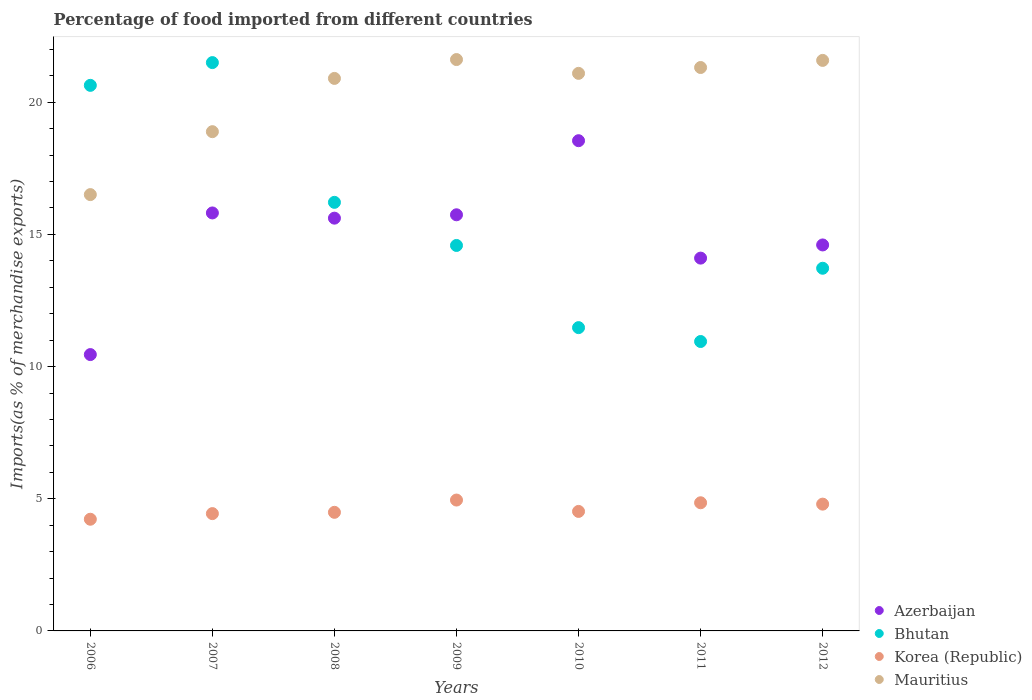How many different coloured dotlines are there?
Your response must be concise. 4. What is the percentage of imports to different countries in Azerbaijan in 2012?
Keep it short and to the point. 14.6. Across all years, what is the maximum percentage of imports to different countries in Mauritius?
Provide a succinct answer. 21.61. Across all years, what is the minimum percentage of imports to different countries in Bhutan?
Your answer should be compact. 10.95. In which year was the percentage of imports to different countries in Mauritius maximum?
Offer a terse response. 2009. What is the total percentage of imports to different countries in Mauritius in the graph?
Give a very brief answer. 141.9. What is the difference between the percentage of imports to different countries in Mauritius in 2007 and that in 2008?
Offer a very short reply. -2.01. What is the difference between the percentage of imports to different countries in Bhutan in 2010 and the percentage of imports to different countries in Azerbaijan in 2008?
Your answer should be compact. -4.14. What is the average percentage of imports to different countries in Mauritius per year?
Provide a short and direct response. 20.27. In the year 2010, what is the difference between the percentage of imports to different countries in Korea (Republic) and percentage of imports to different countries in Azerbaijan?
Your answer should be very brief. -14.02. In how many years, is the percentage of imports to different countries in Azerbaijan greater than 2 %?
Ensure brevity in your answer.  7. What is the ratio of the percentage of imports to different countries in Mauritius in 2006 to that in 2008?
Offer a very short reply. 0.79. Is the percentage of imports to different countries in Bhutan in 2006 less than that in 2011?
Make the answer very short. No. What is the difference between the highest and the second highest percentage of imports to different countries in Mauritius?
Your answer should be compact. 0.03. What is the difference between the highest and the lowest percentage of imports to different countries in Korea (Republic)?
Make the answer very short. 0.73. In how many years, is the percentage of imports to different countries in Bhutan greater than the average percentage of imports to different countries in Bhutan taken over all years?
Offer a terse response. 3. Is the sum of the percentage of imports to different countries in Korea (Republic) in 2007 and 2009 greater than the maximum percentage of imports to different countries in Azerbaijan across all years?
Provide a succinct answer. No. Does the percentage of imports to different countries in Bhutan monotonically increase over the years?
Give a very brief answer. No. Is the percentage of imports to different countries in Mauritius strictly less than the percentage of imports to different countries in Bhutan over the years?
Provide a succinct answer. No. How many years are there in the graph?
Keep it short and to the point. 7. Are the values on the major ticks of Y-axis written in scientific E-notation?
Your answer should be compact. No. Does the graph contain any zero values?
Ensure brevity in your answer.  No. Does the graph contain grids?
Make the answer very short. No. What is the title of the graph?
Your answer should be compact. Percentage of food imported from different countries. Does "Thailand" appear as one of the legend labels in the graph?
Keep it short and to the point. No. What is the label or title of the X-axis?
Keep it short and to the point. Years. What is the label or title of the Y-axis?
Offer a terse response. Imports(as % of merchandise exports). What is the Imports(as % of merchandise exports) in Azerbaijan in 2006?
Make the answer very short. 10.45. What is the Imports(as % of merchandise exports) in Bhutan in 2006?
Make the answer very short. 20.64. What is the Imports(as % of merchandise exports) of Korea (Republic) in 2006?
Give a very brief answer. 4.23. What is the Imports(as % of merchandise exports) of Mauritius in 2006?
Provide a short and direct response. 16.51. What is the Imports(as % of merchandise exports) in Azerbaijan in 2007?
Your answer should be very brief. 15.81. What is the Imports(as % of merchandise exports) in Bhutan in 2007?
Provide a succinct answer. 21.5. What is the Imports(as % of merchandise exports) in Korea (Republic) in 2007?
Keep it short and to the point. 4.44. What is the Imports(as % of merchandise exports) in Mauritius in 2007?
Offer a terse response. 18.89. What is the Imports(as % of merchandise exports) of Azerbaijan in 2008?
Give a very brief answer. 15.61. What is the Imports(as % of merchandise exports) of Bhutan in 2008?
Ensure brevity in your answer.  16.21. What is the Imports(as % of merchandise exports) in Korea (Republic) in 2008?
Make the answer very short. 4.49. What is the Imports(as % of merchandise exports) of Mauritius in 2008?
Give a very brief answer. 20.9. What is the Imports(as % of merchandise exports) of Azerbaijan in 2009?
Your answer should be compact. 15.74. What is the Imports(as % of merchandise exports) of Bhutan in 2009?
Give a very brief answer. 14.58. What is the Imports(as % of merchandise exports) of Korea (Republic) in 2009?
Provide a succinct answer. 4.95. What is the Imports(as % of merchandise exports) of Mauritius in 2009?
Your answer should be very brief. 21.61. What is the Imports(as % of merchandise exports) of Azerbaijan in 2010?
Your answer should be very brief. 18.54. What is the Imports(as % of merchandise exports) in Bhutan in 2010?
Your response must be concise. 11.47. What is the Imports(as % of merchandise exports) of Korea (Republic) in 2010?
Make the answer very short. 4.52. What is the Imports(as % of merchandise exports) of Mauritius in 2010?
Give a very brief answer. 21.09. What is the Imports(as % of merchandise exports) in Azerbaijan in 2011?
Provide a succinct answer. 14.1. What is the Imports(as % of merchandise exports) of Bhutan in 2011?
Your answer should be very brief. 10.95. What is the Imports(as % of merchandise exports) in Korea (Republic) in 2011?
Your answer should be compact. 4.85. What is the Imports(as % of merchandise exports) in Mauritius in 2011?
Ensure brevity in your answer.  21.31. What is the Imports(as % of merchandise exports) of Azerbaijan in 2012?
Offer a terse response. 14.6. What is the Imports(as % of merchandise exports) in Bhutan in 2012?
Your response must be concise. 13.72. What is the Imports(as % of merchandise exports) of Korea (Republic) in 2012?
Keep it short and to the point. 4.8. What is the Imports(as % of merchandise exports) in Mauritius in 2012?
Your answer should be compact. 21.58. Across all years, what is the maximum Imports(as % of merchandise exports) of Azerbaijan?
Ensure brevity in your answer.  18.54. Across all years, what is the maximum Imports(as % of merchandise exports) of Bhutan?
Give a very brief answer. 21.5. Across all years, what is the maximum Imports(as % of merchandise exports) in Korea (Republic)?
Give a very brief answer. 4.95. Across all years, what is the maximum Imports(as % of merchandise exports) in Mauritius?
Give a very brief answer. 21.61. Across all years, what is the minimum Imports(as % of merchandise exports) of Azerbaijan?
Your response must be concise. 10.45. Across all years, what is the minimum Imports(as % of merchandise exports) of Bhutan?
Your answer should be very brief. 10.95. Across all years, what is the minimum Imports(as % of merchandise exports) of Korea (Republic)?
Your answer should be compact. 4.23. Across all years, what is the minimum Imports(as % of merchandise exports) of Mauritius?
Make the answer very short. 16.51. What is the total Imports(as % of merchandise exports) in Azerbaijan in the graph?
Make the answer very short. 104.87. What is the total Imports(as % of merchandise exports) of Bhutan in the graph?
Ensure brevity in your answer.  109.08. What is the total Imports(as % of merchandise exports) of Korea (Republic) in the graph?
Give a very brief answer. 32.27. What is the total Imports(as % of merchandise exports) in Mauritius in the graph?
Give a very brief answer. 141.9. What is the difference between the Imports(as % of merchandise exports) of Azerbaijan in 2006 and that in 2007?
Give a very brief answer. -5.36. What is the difference between the Imports(as % of merchandise exports) of Bhutan in 2006 and that in 2007?
Make the answer very short. -0.86. What is the difference between the Imports(as % of merchandise exports) of Korea (Republic) in 2006 and that in 2007?
Ensure brevity in your answer.  -0.21. What is the difference between the Imports(as % of merchandise exports) of Mauritius in 2006 and that in 2007?
Give a very brief answer. -2.38. What is the difference between the Imports(as % of merchandise exports) of Azerbaijan in 2006 and that in 2008?
Keep it short and to the point. -5.16. What is the difference between the Imports(as % of merchandise exports) in Bhutan in 2006 and that in 2008?
Make the answer very short. 4.43. What is the difference between the Imports(as % of merchandise exports) of Korea (Republic) in 2006 and that in 2008?
Give a very brief answer. -0.26. What is the difference between the Imports(as % of merchandise exports) of Mauritius in 2006 and that in 2008?
Your response must be concise. -4.4. What is the difference between the Imports(as % of merchandise exports) of Azerbaijan in 2006 and that in 2009?
Offer a very short reply. -5.29. What is the difference between the Imports(as % of merchandise exports) of Bhutan in 2006 and that in 2009?
Ensure brevity in your answer.  6.06. What is the difference between the Imports(as % of merchandise exports) of Korea (Republic) in 2006 and that in 2009?
Your response must be concise. -0.73. What is the difference between the Imports(as % of merchandise exports) of Mauritius in 2006 and that in 2009?
Provide a succinct answer. -5.11. What is the difference between the Imports(as % of merchandise exports) in Azerbaijan in 2006 and that in 2010?
Provide a short and direct response. -8.09. What is the difference between the Imports(as % of merchandise exports) of Bhutan in 2006 and that in 2010?
Offer a very short reply. 9.17. What is the difference between the Imports(as % of merchandise exports) in Korea (Republic) in 2006 and that in 2010?
Offer a terse response. -0.3. What is the difference between the Imports(as % of merchandise exports) in Mauritius in 2006 and that in 2010?
Your response must be concise. -4.59. What is the difference between the Imports(as % of merchandise exports) of Azerbaijan in 2006 and that in 2011?
Offer a terse response. -3.65. What is the difference between the Imports(as % of merchandise exports) in Bhutan in 2006 and that in 2011?
Your answer should be compact. 9.69. What is the difference between the Imports(as % of merchandise exports) in Korea (Republic) in 2006 and that in 2011?
Make the answer very short. -0.62. What is the difference between the Imports(as % of merchandise exports) in Mauritius in 2006 and that in 2011?
Give a very brief answer. -4.81. What is the difference between the Imports(as % of merchandise exports) of Azerbaijan in 2006 and that in 2012?
Offer a terse response. -4.15. What is the difference between the Imports(as % of merchandise exports) of Bhutan in 2006 and that in 2012?
Provide a short and direct response. 6.92. What is the difference between the Imports(as % of merchandise exports) in Korea (Republic) in 2006 and that in 2012?
Offer a very short reply. -0.57. What is the difference between the Imports(as % of merchandise exports) of Mauritius in 2006 and that in 2012?
Offer a terse response. -5.08. What is the difference between the Imports(as % of merchandise exports) of Azerbaijan in 2007 and that in 2008?
Offer a terse response. 0.2. What is the difference between the Imports(as % of merchandise exports) in Bhutan in 2007 and that in 2008?
Ensure brevity in your answer.  5.29. What is the difference between the Imports(as % of merchandise exports) of Korea (Republic) in 2007 and that in 2008?
Keep it short and to the point. -0.05. What is the difference between the Imports(as % of merchandise exports) of Mauritius in 2007 and that in 2008?
Make the answer very short. -2.02. What is the difference between the Imports(as % of merchandise exports) of Azerbaijan in 2007 and that in 2009?
Give a very brief answer. 0.07. What is the difference between the Imports(as % of merchandise exports) of Bhutan in 2007 and that in 2009?
Offer a very short reply. 6.92. What is the difference between the Imports(as % of merchandise exports) of Korea (Republic) in 2007 and that in 2009?
Offer a very short reply. -0.51. What is the difference between the Imports(as % of merchandise exports) of Mauritius in 2007 and that in 2009?
Offer a very short reply. -2.73. What is the difference between the Imports(as % of merchandise exports) in Azerbaijan in 2007 and that in 2010?
Offer a terse response. -2.73. What is the difference between the Imports(as % of merchandise exports) of Bhutan in 2007 and that in 2010?
Offer a very short reply. 10.03. What is the difference between the Imports(as % of merchandise exports) in Korea (Republic) in 2007 and that in 2010?
Give a very brief answer. -0.08. What is the difference between the Imports(as % of merchandise exports) of Mauritius in 2007 and that in 2010?
Your response must be concise. -2.21. What is the difference between the Imports(as % of merchandise exports) of Azerbaijan in 2007 and that in 2011?
Provide a short and direct response. 1.71. What is the difference between the Imports(as % of merchandise exports) of Bhutan in 2007 and that in 2011?
Your answer should be very brief. 10.55. What is the difference between the Imports(as % of merchandise exports) in Korea (Republic) in 2007 and that in 2011?
Provide a succinct answer. -0.41. What is the difference between the Imports(as % of merchandise exports) of Mauritius in 2007 and that in 2011?
Keep it short and to the point. -2.43. What is the difference between the Imports(as % of merchandise exports) of Azerbaijan in 2007 and that in 2012?
Ensure brevity in your answer.  1.21. What is the difference between the Imports(as % of merchandise exports) in Bhutan in 2007 and that in 2012?
Provide a succinct answer. 7.78. What is the difference between the Imports(as % of merchandise exports) in Korea (Republic) in 2007 and that in 2012?
Ensure brevity in your answer.  -0.36. What is the difference between the Imports(as % of merchandise exports) in Mauritius in 2007 and that in 2012?
Your answer should be compact. -2.7. What is the difference between the Imports(as % of merchandise exports) of Azerbaijan in 2008 and that in 2009?
Make the answer very short. -0.13. What is the difference between the Imports(as % of merchandise exports) in Bhutan in 2008 and that in 2009?
Your response must be concise. 1.63. What is the difference between the Imports(as % of merchandise exports) in Korea (Republic) in 2008 and that in 2009?
Provide a short and direct response. -0.46. What is the difference between the Imports(as % of merchandise exports) of Mauritius in 2008 and that in 2009?
Give a very brief answer. -0.71. What is the difference between the Imports(as % of merchandise exports) in Azerbaijan in 2008 and that in 2010?
Offer a terse response. -2.93. What is the difference between the Imports(as % of merchandise exports) in Bhutan in 2008 and that in 2010?
Provide a short and direct response. 4.74. What is the difference between the Imports(as % of merchandise exports) of Korea (Republic) in 2008 and that in 2010?
Keep it short and to the point. -0.03. What is the difference between the Imports(as % of merchandise exports) in Mauritius in 2008 and that in 2010?
Offer a very short reply. -0.19. What is the difference between the Imports(as % of merchandise exports) in Azerbaijan in 2008 and that in 2011?
Your answer should be compact. 1.51. What is the difference between the Imports(as % of merchandise exports) in Bhutan in 2008 and that in 2011?
Keep it short and to the point. 5.26. What is the difference between the Imports(as % of merchandise exports) in Korea (Republic) in 2008 and that in 2011?
Make the answer very short. -0.36. What is the difference between the Imports(as % of merchandise exports) in Mauritius in 2008 and that in 2011?
Give a very brief answer. -0.41. What is the difference between the Imports(as % of merchandise exports) of Azerbaijan in 2008 and that in 2012?
Your response must be concise. 1.01. What is the difference between the Imports(as % of merchandise exports) in Bhutan in 2008 and that in 2012?
Offer a very short reply. 2.49. What is the difference between the Imports(as % of merchandise exports) of Korea (Republic) in 2008 and that in 2012?
Your answer should be compact. -0.31. What is the difference between the Imports(as % of merchandise exports) in Mauritius in 2008 and that in 2012?
Your response must be concise. -0.68. What is the difference between the Imports(as % of merchandise exports) of Azerbaijan in 2009 and that in 2010?
Keep it short and to the point. -2.8. What is the difference between the Imports(as % of merchandise exports) of Bhutan in 2009 and that in 2010?
Your answer should be compact. 3.11. What is the difference between the Imports(as % of merchandise exports) in Korea (Republic) in 2009 and that in 2010?
Make the answer very short. 0.43. What is the difference between the Imports(as % of merchandise exports) of Mauritius in 2009 and that in 2010?
Offer a terse response. 0.52. What is the difference between the Imports(as % of merchandise exports) of Azerbaijan in 2009 and that in 2011?
Your answer should be compact. 1.64. What is the difference between the Imports(as % of merchandise exports) in Bhutan in 2009 and that in 2011?
Offer a very short reply. 3.63. What is the difference between the Imports(as % of merchandise exports) of Korea (Republic) in 2009 and that in 2011?
Provide a succinct answer. 0.1. What is the difference between the Imports(as % of merchandise exports) of Mauritius in 2009 and that in 2011?
Your answer should be compact. 0.3. What is the difference between the Imports(as % of merchandise exports) of Azerbaijan in 2009 and that in 2012?
Make the answer very short. 1.14. What is the difference between the Imports(as % of merchandise exports) of Bhutan in 2009 and that in 2012?
Make the answer very short. 0.86. What is the difference between the Imports(as % of merchandise exports) of Korea (Republic) in 2009 and that in 2012?
Your answer should be compact. 0.15. What is the difference between the Imports(as % of merchandise exports) in Mauritius in 2009 and that in 2012?
Keep it short and to the point. 0.03. What is the difference between the Imports(as % of merchandise exports) of Azerbaijan in 2010 and that in 2011?
Offer a terse response. 4.44. What is the difference between the Imports(as % of merchandise exports) in Bhutan in 2010 and that in 2011?
Your answer should be very brief. 0.52. What is the difference between the Imports(as % of merchandise exports) of Korea (Republic) in 2010 and that in 2011?
Your answer should be compact. -0.33. What is the difference between the Imports(as % of merchandise exports) of Mauritius in 2010 and that in 2011?
Your answer should be compact. -0.22. What is the difference between the Imports(as % of merchandise exports) in Azerbaijan in 2010 and that in 2012?
Provide a short and direct response. 3.94. What is the difference between the Imports(as % of merchandise exports) of Bhutan in 2010 and that in 2012?
Keep it short and to the point. -2.25. What is the difference between the Imports(as % of merchandise exports) of Korea (Republic) in 2010 and that in 2012?
Keep it short and to the point. -0.28. What is the difference between the Imports(as % of merchandise exports) of Mauritius in 2010 and that in 2012?
Your answer should be very brief. -0.49. What is the difference between the Imports(as % of merchandise exports) of Azerbaijan in 2011 and that in 2012?
Offer a terse response. -0.5. What is the difference between the Imports(as % of merchandise exports) of Bhutan in 2011 and that in 2012?
Ensure brevity in your answer.  -2.77. What is the difference between the Imports(as % of merchandise exports) in Korea (Republic) in 2011 and that in 2012?
Give a very brief answer. 0.05. What is the difference between the Imports(as % of merchandise exports) in Mauritius in 2011 and that in 2012?
Your answer should be compact. -0.27. What is the difference between the Imports(as % of merchandise exports) in Azerbaijan in 2006 and the Imports(as % of merchandise exports) in Bhutan in 2007?
Your answer should be very brief. -11.05. What is the difference between the Imports(as % of merchandise exports) of Azerbaijan in 2006 and the Imports(as % of merchandise exports) of Korea (Republic) in 2007?
Your response must be concise. 6.02. What is the difference between the Imports(as % of merchandise exports) in Azerbaijan in 2006 and the Imports(as % of merchandise exports) in Mauritius in 2007?
Ensure brevity in your answer.  -8.43. What is the difference between the Imports(as % of merchandise exports) of Bhutan in 2006 and the Imports(as % of merchandise exports) of Korea (Republic) in 2007?
Provide a short and direct response. 16.2. What is the difference between the Imports(as % of merchandise exports) of Bhutan in 2006 and the Imports(as % of merchandise exports) of Mauritius in 2007?
Give a very brief answer. 1.75. What is the difference between the Imports(as % of merchandise exports) of Korea (Republic) in 2006 and the Imports(as % of merchandise exports) of Mauritius in 2007?
Give a very brief answer. -14.66. What is the difference between the Imports(as % of merchandise exports) of Azerbaijan in 2006 and the Imports(as % of merchandise exports) of Bhutan in 2008?
Give a very brief answer. -5.76. What is the difference between the Imports(as % of merchandise exports) in Azerbaijan in 2006 and the Imports(as % of merchandise exports) in Korea (Republic) in 2008?
Provide a succinct answer. 5.97. What is the difference between the Imports(as % of merchandise exports) of Azerbaijan in 2006 and the Imports(as % of merchandise exports) of Mauritius in 2008?
Provide a short and direct response. -10.45. What is the difference between the Imports(as % of merchandise exports) in Bhutan in 2006 and the Imports(as % of merchandise exports) in Korea (Republic) in 2008?
Your answer should be compact. 16.15. What is the difference between the Imports(as % of merchandise exports) of Bhutan in 2006 and the Imports(as % of merchandise exports) of Mauritius in 2008?
Make the answer very short. -0.26. What is the difference between the Imports(as % of merchandise exports) of Korea (Republic) in 2006 and the Imports(as % of merchandise exports) of Mauritius in 2008?
Offer a terse response. -16.68. What is the difference between the Imports(as % of merchandise exports) in Azerbaijan in 2006 and the Imports(as % of merchandise exports) in Bhutan in 2009?
Your answer should be very brief. -4.13. What is the difference between the Imports(as % of merchandise exports) of Azerbaijan in 2006 and the Imports(as % of merchandise exports) of Korea (Republic) in 2009?
Your response must be concise. 5.5. What is the difference between the Imports(as % of merchandise exports) in Azerbaijan in 2006 and the Imports(as % of merchandise exports) in Mauritius in 2009?
Keep it short and to the point. -11.16. What is the difference between the Imports(as % of merchandise exports) of Bhutan in 2006 and the Imports(as % of merchandise exports) of Korea (Republic) in 2009?
Give a very brief answer. 15.69. What is the difference between the Imports(as % of merchandise exports) in Bhutan in 2006 and the Imports(as % of merchandise exports) in Mauritius in 2009?
Keep it short and to the point. -0.98. What is the difference between the Imports(as % of merchandise exports) in Korea (Republic) in 2006 and the Imports(as % of merchandise exports) in Mauritius in 2009?
Make the answer very short. -17.39. What is the difference between the Imports(as % of merchandise exports) in Azerbaijan in 2006 and the Imports(as % of merchandise exports) in Bhutan in 2010?
Provide a short and direct response. -1.02. What is the difference between the Imports(as % of merchandise exports) in Azerbaijan in 2006 and the Imports(as % of merchandise exports) in Korea (Republic) in 2010?
Ensure brevity in your answer.  5.93. What is the difference between the Imports(as % of merchandise exports) in Azerbaijan in 2006 and the Imports(as % of merchandise exports) in Mauritius in 2010?
Provide a succinct answer. -10.64. What is the difference between the Imports(as % of merchandise exports) in Bhutan in 2006 and the Imports(as % of merchandise exports) in Korea (Republic) in 2010?
Your response must be concise. 16.12. What is the difference between the Imports(as % of merchandise exports) of Bhutan in 2006 and the Imports(as % of merchandise exports) of Mauritius in 2010?
Your response must be concise. -0.45. What is the difference between the Imports(as % of merchandise exports) in Korea (Republic) in 2006 and the Imports(as % of merchandise exports) in Mauritius in 2010?
Give a very brief answer. -16.87. What is the difference between the Imports(as % of merchandise exports) of Azerbaijan in 2006 and the Imports(as % of merchandise exports) of Bhutan in 2011?
Your response must be concise. -0.49. What is the difference between the Imports(as % of merchandise exports) of Azerbaijan in 2006 and the Imports(as % of merchandise exports) of Korea (Republic) in 2011?
Your answer should be compact. 5.61. What is the difference between the Imports(as % of merchandise exports) in Azerbaijan in 2006 and the Imports(as % of merchandise exports) in Mauritius in 2011?
Offer a very short reply. -10.86. What is the difference between the Imports(as % of merchandise exports) of Bhutan in 2006 and the Imports(as % of merchandise exports) of Korea (Republic) in 2011?
Ensure brevity in your answer.  15.79. What is the difference between the Imports(as % of merchandise exports) of Bhutan in 2006 and the Imports(as % of merchandise exports) of Mauritius in 2011?
Provide a succinct answer. -0.67. What is the difference between the Imports(as % of merchandise exports) of Korea (Republic) in 2006 and the Imports(as % of merchandise exports) of Mauritius in 2011?
Provide a succinct answer. -17.09. What is the difference between the Imports(as % of merchandise exports) of Azerbaijan in 2006 and the Imports(as % of merchandise exports) of Bhutan in 2012?
Provide a succinct answer. -3.27. What is the difference between the Imports(as % of merchandise exports) in Azerbaijan in 2006 and the Imports(as % of merchandise exports) in Korea (Republic) in 2012?
Provide a succinct answer. 5.66. What is the difference between the Imports(as % of merchandise exports) in Azerbaijan in 2006 and the Imports(as % of merchandise exports) in Mauritius in 2012?
Your response must be concise. -11.13. What is the difference between the Imports(as % of merchandise exports) in Bhutan in 2006 and the Imports(as % of merchandise exports) in Korea (Republic) in 2012?
Make the answer very short. 15.84. What is the difference between the Imports(as % of merchandise exports) in Bhutan in 2006 and the Imports(as % of merchandise exports) in Mauritius in 2012?
Offer a very short reply. -0.94. What is the difference between the Imports(as % of merchandise exports) of Korea (Republic) in 2006 and the Imports(as % of merchandise exports) of Mauritius in 2012?
Your answer should be compact. -17.36. What is the difference between the Imports(as % of merchandise exports) in Azerbaijan in 2007 and the Imports(as % of merchandise exports) in Bhutan in 2008?
Provide a succinct answer. -0.4. What is the difference between the Imports(as % of merchandise exports) in Azerbaijan in 2007 and the Imports(as % of merchandise exports) in Korea (Republic) in 2008?
Provide a succinct answer. 11.33. What is the difference between the Imports(as % of merchandise exports) in Azerbaijan in 2007 and the Imports(as % of merchandise exports) in Mauritius in 2008?
Offer a terse response. -5.09. What is the difference between the Imports(as % of merchandise exports) of Bhutan in 2007 and the Imports(as % of merchandise exports) of Korea (Republic) in 2008?
Your answer should be compact. 17.01. What is the difference between the Imports(as % of merchandise exports) of Bhutan in 2007 and the Imports(as % of merchandise exports) of Mauritius in 2008?
Provide a succinct answer. 0.6. What is the difference between the Imports(as % of merchandise exports) of Korea (Republic) in 2007 and the Imports(as % of merchandise exports) of Mauritius in 2008?
Provide a succinct answer. -16.46. What is the difference between the Imports(as % of merchandise exports) of Azerbaijan in 2007 and the Imports(as % of merchandise exports) of Bhutan in 2009?
Your answer should be compact. 1.23. What is the difference between the Imports(as % of merchandise exports) of Azerbaijan in 2007 and the Imports(as % of merchandise exports) of Korea (Republic) in 2009?
Your answer should be compact. 10.86. What is the difference between the Imports(as % of merchandise exports) in Azerbaijan in 2007 and the Imports(as % of merchandise exports) in Mauritius in 2009?
Your answer should be compact. -5.8. What is the difference between the Imports(as % of merchandise exports) of Bhutan in 2007 and the Imports(as % of merchandise exports) of Korea (Republic) in 2009?
Your answer should be very brief. 16.55. What is the difference between the Imports(as % of merchandise exports) of Bhutan in 2007 and the Imports(as % of merchandise exports) of Mauritius in 2009?
Provide a short and direct response. -0.11. What is the difference between the Imports(as % of merchandise exports) of Korea (Republic) in 2007 and the Imports(as % of merchandise exports) of Mauritius in 2009?
Keep it short and to the point. -17.18. What is the difference between the Imports(as % of merchandise exports) in Azerbaijan in 2007 and the Imports(as % of merchandise exports) in Bhutan in 2010?
Provide a short and direct response. 4.34. What is the difference between the Imports(as % of merchandise exports) in Azerbaijan in 2007 and the Imports(as % of merchandise exports) in Korea (Republic) in 2010?
Offer a very short reply. 11.29. What is the difference between the Imports(as % of merchandise exports) of Azerbaijan in 2007 and the Imports(as % of merchandise exports) of Mauritius in 2010?
Your answer should be very brief. -5.28. What is the difference between the Imports(as % of merchandise exports) of Bhutan in 2007 and the Imports(as % of merchandise exports) of Korea (Republic) in 2010?
Provide a short and direct response. 16.98. What is the difference between the Imports(as % of merchandise exports) of Bhutan in 2007 and the Imports(as % of merchandise exports) of Mauritius in 2010?
Offer a very short reply. 0.41. What is the difference between the Imports(as % of merchandise exports) in Korea (Republic) in 2007 and the Imports(as % of merchandise exports) in Mauritius in 2010?
Provide a succinct answer. -16.65. What is the difference between the Imports(as % of merchandise exports) in Azerbaijan in 2007 and the Imports(as % of merchandise exports) in Bhutan in 2011?
Keep it short and to the point. 4.86. What is the difference between the Imports(as % of merchandise exports) of Azerbaijan in 2007 and the Imports(as % of merchandise exports) of Korea (Republic) in 2011?
Your answer should be compact. 10.96. What is the difference between the Imports(as % of merchandise exports) of Azerbaijan in 2007 and the Imports(as % of merchandise exports) of Mauritius in 2011?
Offer a very short reply. -5.5. What is the difference between the Imports(as % of merchandise exports) of Bhutan in 2007 and the Imports(as % of merchandise exports) of Korea (Republic) in 2011?
Keep it short and to the point. 16.65. What is the difference between the Imports(as % of merchandise exports) of Bhutan in 2007 and the Imports(as % of merchandise exports) of Mauritius in 2011?
Provide a short and direct response. 0.19. What is the difference between the Imports(as % of merchandise exports) in Korea (Republic) in 2007 and the Imports(as % of merchandise exports) in Mauritius in 2011?
Your response must be concise. -16.88. What is the difference between the Imports(as % of merchandise exports) in Azerbaijan in 2007 and the Imports(as % of merchandise exports) in Bhutan in 2012?
Offer a terse response. 2.09. What is the difference between the Imports(as % of merchandise exports) in Azerbaijan in 2007 and the Imports(as % of merchandise exports) in Korea (Republic) in 2012?
Keep it short and to the point. 11.02. What is the difference between the Imports(as % of merchandise exports) of Azerbaijan in 2007 and the Imports(as % of merchandise exports) of Mauritius in 2012?
Your response must be concise. -5.77. What is the difference between the Imports(as % of merchandise exports) of Bhutan in 2007 and the Imports(as % of merchandise exports) of Korea (Republic) in 2012?
Your answer should be very brief. 16.7. What is the difference between the Imports(as % of merchandise exports) in Bhutan in 2007 and the Imports(as % of merchandise exports) in Mauritius in 2012?
Provide a short and direct response. -0.08. What is the difference between the Imports(as % of merchandise exports) of Korea (Republic) in 2007 and the Imports(as % of merchandise exports) of Mauritius in 2012?
Offer a very short reply. -17.15. What is the difference between the Imports(as % of merchandise exports) of Azerbaijan in 2008 and the Imports(as % of merchandise exports) of Bhutan in 2009?
Offer a very short reply. 1.03. What is the difference between the Imports(as % of merchandise exports) of Azerbaijan in 2008 and the Imports(as % of merchandise exports) of Korea (Republic) in 2009?
Your response must be concise. 10.66. What is the difference between the Imports(as % of merchandise exports) in Azerbaijan in 2008 and the Imports(as % of merchandise exports) in Mauritius in 2009?
Provide a succinct answer. -6. What is the difference between the Imports(as % of merchandise exports) of Bhutan in 2008 and the Imports(as % of merchandise exports) of Korea (Republic) in 2009?
Provide a succinct answer. 11.26. What is the difference between the Imports(as % of merchandise exports) of Bhutan in 2008 and the Imports(as % of merchandise exports) of Mauritius in 2009?
Your response must be concise. -5.4. What is the difference between the Imports(as % of merchandise exports) in Korea (Republic) in 2008 and the Imports(as % of merchandise exports) in Mauritius in 2009?
Your response must be concise. -17.13. What is the difference between the Imports(as % of merchandise exports) in Azerbaijan in 2008 and the Imports(as % of merchandise exports) in Bhutan in 2010?
Your response must be concise. 4.14. What is the difference between the Imports(as % of merchandise exports) of Azerbaijan in 2008 and the Imports(as % of merchandise exports) of Korea (Republic) in 2010?
Your answer should be very brief. 11.09. What is the difference between the Imports(as % of merchandise exports) of Azerbaijan in 2008 and the Imports(as % of merchandise exports) of Mauritius in 2010?
Ensure brevity in your answer.  -5.48. What is the difference between the Imports(as % of merchandise exports) of Bhutan in 2008 and the Imports(as % of merchandise exports) of Korea (Republic) in 2010?
Your answer should be compact. 11.69. What is the difference between the Imports(as % of merchandise exports) in Bhutan in 2008 and the Imports(as % of merchandise exports) in Mauritius in 2010?
Ensure brevity in your answer.  -4.88. What is the difference between the Imports(as % of merchandise exports) in Korea (Republic) in 2008 and the Imports(as % of merchandise exports) in Mauritius in 2010?
Provide a succinct answer. -16.61. What is the difference between the Imports(as % of merchandise exports) in Azerbaijan in 2008 and the Imports(as % of merchandise exports) in Bhutan in 2011?
Provide a short and direct response. 4.67. What is the difference between the Imports(as % of merchandise exports) of Azerbaijan in 2008 and the Imports(as % of merchandise exports) of Korea (Republic) in 2011?
Offer a very short reply. 10.77. What is the difference between the Imports(as % of merchandise exports) in Azerbaijan in 2008 and the Imports(as % of merchandise exports) in Mauritius in 2011?
Ensure brevity in your answer.  -5.7. What is the difference between the Imports(as % of merchandise exports) of Bhutan in 2008 and the Imports(as % of merchandise exports) of Korea (Republic) in 2011?
Offer a very short reply. 11.36. What is the difference between the Imports(as % of merchandise exports) of Bhutan in 2008 and the Imports(as % of merchandise exports) of Mauritius in 2011?
Ensure brevity in your answer.  -5.1. What is the difference between the Imports(as % of merchandise exports) in Korea (Republic) in 2008 and the Imports(as % of merchandise exports) in Mauritius in 2011?
Your answer should be very brief. -16.83. What is the difference between the Imports(as % of merchandise exports) of Azerbaijan in 2008 and the Imports(as % of merchandise exports) of Bhutan in 2012?
Offer a very short reply. 1.9. What is the difference between the Imports(as % of merchandise exports) in Azerbaijan in 2008 and the Imports(as % of merchandise exports) in Korea (Republic) in 2012?
Your response must be concise. 10.82. What is the difference between the Imports(as % of merchandise exports) in Azerbaijan in 2008 and the Imports(as % of merchandise exports) in Mauritius in 2012?
Ensure brevity in your answer.  -5.97. What is the difference between the Imports(as % of merchandise exports) in Bhutan in 2008 and the Imports(as % of merchandise exports) in Korea (Republic) in 2012?
Ensure brevity in your answer.  11.42. What is the difference between the Imports(as % of merchandise exports) in Bhutan in 2008 and the Imports(as % of merchandise exports) in Mauritius in 2012?
Offer a very short reply. -5.37. What is the difference between the Imports(as % of merchandise exports) of Korea (Republic) in 2008 and the Imports(as % of merchandise exports) of Mauritius in 2012?
Provide a short and direct response. -17.1. What is the difference between the Imports(as % of merchandise exports) in Azerbaijan in 2009 and the Imports(as % of merchandise exports) in Bhutan in 2010?
Provide a short and direct response. 4.27. What is the difference between the Imports(as % of merchandise exports) of Azerbaijan in 2009 and the Imports(as % of merchandise exports) of Korea (Republic) in 2010?
Provide a succinct answer. 11.22. What is the difference between the Imports(as % of merchandise exports) in Azerbaijan in 2009 and the Imports(as % of merchandise exports) in Mauritius in 2010?
Your answer should be very brief. -5.35. What is the difference between the Imports(as % of merchandise exports) in Bhutan in 2009 and the Imports(as % of merchandise exports) in Korea (Republic) in 2010?
Your answer should be compact. 10.06. What is the difference between the Imports(as % of merchandise exports) in Bhutan in 2009 and the Imports(as % of merchandise exports) in Mauritius in 2010?
Give a very brief answer. -6.51. What is the difference between the Imports(as % of merchandise exports) in Korea (Republic) in 2009 and the Imports(as % of merchandise exports) in Mauritius in 2010?
Your answer should be compact. -16.14. What is the difference between the Imports(as % of merchandise exports) of Azerbaijan in 2009 and the Imports(as % of merchandise exports) of Bhutan in 2011?
Offer a terse response. 4.79. What is the difference between the Imports(as % of merchandise exports) in Azerbaijan in 2009 and the Imports(as % of merchandise exports) in Korea (Republic) in 2011?
Offer a very short reply. 10.89. What is the difference between the Imports(as % of merchandise exports) of Azerbaijan in 2009 and the Imports(as % of merchandise exports) of Mauritius in 2011?
Give a very brief answer. -5.57. What is the difference between the Imports(as % of merchandise exports) in Bhutan in 2009 and the Imports(as % of merchandise exports) in Korea (Republic) in 2011?
Ensure brevity in your answer.  9.73. What is the difference between the Imports(as % of merchandise exports) in Bhutan in 2009 and the Imports(as % of merchandise exports) in Mauritius in 2011?
Your answer should be compact. -6.73. What is the difference between the Imports(as % of merchandise exports) of Korea (Republic) in 2009 and the Imports(as % of merchandise exports) of Mauritius in 2011?
Keep it short and to the point. -16.36. What is the difference between the Imports(as % of merchandise exports) in Azerbaijan in 2009 and the Imports(as % of merchandise exports) in Bhutan in 2012?
Your answer should be very brief. 2.02. What is the difference between the Imports(as % of merchandise exports) of Azerbaijan in 2009 and the Imports(as % of merchandise exports) of Korea (Republic) in 2012?
Your answer should be very brief. 10.95. What is the difference between the Imports(as % of merchandise exports) of Azerbaijan in 2009 and the Imports(as % of merchandise exports) of Mauritius in 2012?
Your response must be concise. -5.84. What is the difference between the Imports(as % of merchandise exports) in Bhutan in 2009 and the Imports(as % of merchandise exports) in Korea (Republic) in 2012?
Your answer should be very brief. 9.79. What is the difference between the Imports(as % of merchandise exports) of Bhutan in 2009 and the Imports(as % of merchandise exports) of Mauritius in 2012?
Provide a succinct answer. -7. What is the difference between the Imports(as % of merchandise exports) in Korea (Republic) in 2009 and the Imports(as % of merchandise exports) in Mauritius in 2012?
Your response must be concise. -16.63. What is the difference between the Imports(as % of merchandise exports) of Azerbaijan in 2010 and the Imports(as % of merchandise exports) of Bhutan in 2011?
Give a very brief answer. 7.6. What is the difference between the Imports(as % of merchandise exports) of Azerbaijan in 2010 and the Imports(as % of merchandise exports) of Korea (Republic) in 2011?
Keep it short and to the point. 13.7. What is the difference between the Imports(as % of merchandise exports) of Azerbaijan in 2010 and the Imports(as % of merchandise exports) of Mauritius in 2011?
Ensure brevity in your answer.  -2.77. What is the difference between the Imports(as % of merchandise exports) of Bhutan in 2010 and the Imports(as % of merchandise exports) of Korea (Republic) in 2011?
Provide a succinct answer. 6.63. What is the difference between the Imports(as % of merchandise exports) of Bhutan in 2010 and the Imports(as % of merchandise exports) of Mauritius in 2011?
Offer a very short reply. -9.84. What is the difference between the Imports(as % of merchandise exports) of Korea (Republic) in 2010 and the Imports(as % of merchandise exports) of Mauritius in 2011?
Ensure brevity in your answer.  -16.79. What is the difference between the Imports(as % of merchandise exports) of Azerbaijan in 2010 and the Imports(as % of merchandise exports) of Bhutan in 2012?
Make the answer very short. 4.83. What is the difference between the Imports(as % of merchandise exports) of Azerbaijan in 2010 and the Imports(as % of merchandise exports) of Korea (Republic) in 2012?
Provide a short and direct response. 13.75. What is the difference between the Imports(as % of merchandise exports) of Azerbaijan in 2010 and the Imports(as % of merchandise exports) of Mauritius in 2012?
Give a very brief answer. -3.04. What is the difference between the Imports(as % of merchandise exports) in Bhutan in 2010 and the Imports(as % of merchandise exports) in Korea (Republic) in 2012?
Give a very brief answer. 6.68. What is the difference between the Imports(as % of merchandise exports) of Bhutan in 2010 and the Imports(as % of merchandise exports) of Mauritius in 2012?
Keep it short and to the point. -10.11. What is the difference between the Imports(as % of merchandise exports) of Korea (Republic) in 2010 and the Imports(as % of merchandise exports) of Mauritius in 2012?
Offer a very short reply. -17.06. What is the difference between the Imports(as % of merchandise exports) in Azerbaijan in 2011 and the Imports(as % of merchandise exports) in Bhutan in 2012?
Offer a terse response. 0.38. What is the difference between the Imports(as % of merchandise exports) in Azerbaijan in 2011 and the Imports(as % of merchandise exports) in Korea (Republic) in 2012?
Give a very brief answer. 9.31. What is the difference between the Imports(as % of merchandise exports) of Azerbaijan in 2011 and the Imports(as % of merchandise exports) of Mauritius in 2012?
Provide a short and direct response. -7.48. What is the difference between the Imports(as % of merchandise exports) of Bhutan in 2011 and the Imports(as % of merchandise exports) of Korea (Republic) in 2012?
Your answer should be very brief. 6.15. What is the difference between the Imports(as % of merchandise exports) in Bhutan in 2011 and the Imports(as % of merchandise exports) in Mauritius in 2012?
Provide a succinct answer. -10.63. What is the difference between the Imports(as % of merchandise exports) in Korea (Republic) in 2011 and the Imports(as % of merchandise exports) in Mauritius in 2012?
Offer a very short reply. -16.73. What is the average Imports(as % of merchandise exports) of Azerbaijan per year?
Your answer should be compact. 14.98. What is the average Imports(as % of merchandise exports) of Bhutan per year?
Your answer should be very brief. 15.58. What is the average Imports(as % of merchandise exports) in Korea (Republic) per year?
Make the answer very short. 4.61. What is the average Imports(as % of merchandise exports) in Mauritius per year?
Offer a very short reply. 20.27. In the year 2006, what is the difference between the Imports(as % of merchandise exports) in Azerbaijan and Imports(as % of merchandise exports) in Bhutan?
Provide a succinct answer. -10.19. In the year 2006, what is the difference between the Imports(as % of merchandise exports) in Azerbaijan and Imports(as % of merchandise exports) in Korea (Republic)?
Your response must be concise. 6.23. In the year 2006, what is the difference between the Imports(as % of merchandise exports) of Azerbaijan and Imports(as % of merchandise exports) of Mauritius?
Your response must be concise. -6.05. In the year 2006, what is the difference between the Imports(as % of merchandise exports) of Bhutan and Imports(as % of merchandise exports) of Korea (Republic)?
Offer a terse response. 16.41. In the year 2006, what is the difference between the Imports(as % of merchandise exports) of Bhutan and Imports(as % of merchandise exports) of Mauritius?
Give a very brief answer. 4.13. In the year 2006, what is the difference between the Imports(as % of merchandise exports) of Korea (Republic) and Imports(as % of merchandise exports) of Mauritius?
Offer a very short reply. -12.28. In the year 2007, what is the difference between the Imports(as % of merchandise exports) of Azerbaijan and Imports(as % of merchandise exports) of Bhutan?
Your answer should be compact. -5.69. In the year 2007, what is the difference between the Imports(as % of merchandise exports) of Azerbaijan and Imports(as % of merchandise exports) of Korea (Republic)?
Your answer should be very brief. 11.37. In the year 2007, what is the difference between the Imports(as % of merchandise exports) in Azerbaijan and Imports(as % of merchandise exports) in Mauritius?
Keep it short and to the point. -3.07. In the year 2007, what is the difference between the Imports(as % of merchandise exports) of Bhutan and Imports(as % of merchandise exports) of Korea (Republic)?
Make the answer very short. 17.06. In the year 2007, what is the difference between the Imports(as % of merchandise exports) in Bhutan and Imports(as % of merchandise exports) in Mauritius?
Your answer should be very brief. 2.61. In the year 2007, what is the difference between the Imports(as % of merchandise exports) in Korea (Republic) and Imports(as % of merchandise exports) in Mauritius?
Offer a terse response. -14.45. In the year 2008, what is the difference between the Imports(as % of merchandise exports) of Azerbaijan and Imports(as % of merchandise exports) of Bhutan?
Make the answer very short. -0.6. In the year 2008, what is the difference between the Imports(as % of merchandise exports) of Azerbaijan and Imports(as % of merchandise exports) of Korea (Republic)?
Provide a succinct answer. 11.13. In the year 2008, what is the difference between the Imports(as % of merchandise exports) of Azerbaijan and Imports(as % of merchandise exports) of Mauritius?
Your answer should be very brief. -5.29. In the year 2008, what is the difference between the Imports(as % of merchandise exports) in Bhutan and Imports(as % of merchandise exports) in Korea (Republic)?
Offer a terse response. 11.73. In the year 2008, what is the difference between the Imports(as % of merchandise exports) in Bhutan and Imports(as % of merchandise exports) in Mauritius?
Offer a very short reply. -4.69. In the year 2008, what is the difference between the Imports(as % of merchandise exports) of Korea (Republic) and Imports(as % of merchandise exports) of Mauritius?
Your answer should be very brief. -16.41. In the year 2009, what is the difference between the Imports(as % of merchandise exports) of Azerbaijan and Imports(as % of merchandise exports) of Bhutan?
Offer a very short reply. 1.16. In the year 2009, what is the difference between the Imports(as % of merchandise exports) of Azerbaijan and Imports(as % of merchandise exports) of Korea (Republic)?
Your response must be concise. 10.79. In the year 2009, what is the difference between the Imports(as % of merchandise exports) of Azerbaijan and Imports(as % of merchandise exports) of Mauritius?
Ensure brevity in your answer.  -5.87. In the year 2009, what is the difference between the Imports(as % of merchandise exports) of Bhutan and Imports(as % of merchandise exports) of Korea (Republic)?
Your answer should be compact. 9.63. In the year 2009, what is the difference between the Imports(as % of merchandise exports) in Bhutan and Imports(as % of merchandise exports) in Mauritius?
Your answer should be compact. -7.03. In the year 2009, what is the difference between the Imports(as % of merchandise exports) of Korea (Republic) and Imports(as % of merchandise exports) of Mauritius?
Keep it short and to the point. -16.66. In the year 2010, what is the difference between the Imports(as % of merchandise exports) in Azerbaijan and Imports(as % of merchandise exports) in Bhutan?
Your response must be concise. 7.07. In the year 2010, what is the difference between the Imports(as % of merchandise exports) in Azerbaijan and Imports(as % of merchandise exports) in Korea (Republic)?
Ensure brevity in your answer.  14.02. In the year 2010, what is the difference between the Imports(as % of merchandise exports) in Azerbaijan and Imports(as % of merchandise exports) in Mauritius?
Keep it short and to the point. -2.55. In the year 2010, what is the difference between the Imports(as % of merchandise exports) of Bhutan and Imports(as % of merchandise exports) of Korea (Republic)?
Offer a terse response. 6.95. In the year 2010, what is the difference between the Imports(as % of merchandise exports) in Bhutan and Imports(as % of merchandise exports) in Mauritius?
Provide a short and direct response. -9.62. In the year 2010, what is the difference between the Imports(as % of merchandise exports) in Korea (Republic) and Imports(as % of merchandise exports) in Mauritius?
Ensure brevity in your answer.  -16.57. In the year 2011, what is the difference between the Imports(as % of merchandise exports) in Azerbaijan and Imports(as % of merchandise exports) in Bhutan?
Ensure brevity in your answer.  3.15. In the year 2011, what is the difference between the Imports(as % of merchandise exports) in Azerbaijan and Imports(as % of merchandise exports) in Korea (Republic)?
Offer a very short reply. 9.26. In the year 2011, what is the difference between the Imports(as % of merchandise exports) in Azerbaijan and Imports(as % of merchandise exports) in Mauritius?
Ensure brevity in your answer.  -7.21. In the year 2011, what is the difference between the Imports(as % of merchandise exports) in Bhutan and Imports(as % of merchandise exports) in Korea (Republic)?
Provide a succinct answer. 6.1. In the year 2011, what is the difference between the Imports(as % of merchandise exports) of Bhutan and Imports(as % of merchandise exports) of Mauritius?
Your answer should be very brief. -10.37. In the year 2011, what is the difference between the Imports(as % of merchandise exports) in Korea (Republic) and Imports(as % of merchandise exports) in Mauritius?
Keep it short and to the point. -16.47. In the year 2012, what is the difference between the Imports(as % of merchandise exports) in Azerbaijan and Imports(as % of merchandise exports) in Bhutan?
Make the answer very short. 0.88. In the year 2012, what is the difference between the Imports(as % of merchandise exports) in Azerbaijan and Imports(as % of merchandise exports) in Korea (Republic)?
Ensure brevity in your answer.  9.81. In the year 2012, what is the difference between the Imports(as % of merchandise exports) of Azerbaijan and Imports(as % of merchandise exports) of Mauritius?
Your answer should be very brief. -6.98. In the year 2012, what is the difference between the Imports(as % of merchandise exports) in Bhutan and Imports(as % of merchandise exports) in Korea (Republic)?
Provide a short and direct response. 8.92. In the year 2012, what is the difference between the Imports(as % of merchandise exports) of Bhutan and Imports(as % of merchandise exports) of Mauritius?
Your answer should be compact. -7.86. In the year 2012, what is the difference between the Imports(as % of merchandise exports) of Korea (Republic) and Imports(as % of merchandise exports) of Mauritius?
Give a very brief answer. -16.79. What is the ratio of the Imports(as % of merchandise exports) of Azerbaijan in 2006 to that in 2007?
Your answer should be compact. 0.66. What is the ratio of the Imports(as % of merchandise exports) in Bhutan in 2006 to that in 2007?
Offer a very short reply. 0.96. What is the ratio of the Imports(as % of merchandise exports) in Korea (Republic) in 2006 to that in 2007?
Your answer should be compact. 0.95. What is the ratio of the Imports(as % of merchandise exports) in Mauritius in 2006 to that in 2007?
Your response must be concise. 0.87. What is the ratio of the Imports(as % of merchandise exports) in Azerbaijan in 2006 to that in 2008?
Your answer should be very brief. 0.67. What is the ratio of the Imports(as % of merchandise exports) in Bhutan in 2006 to that in 2008?
Your response must be concise. 1.27. What is the ratio of the Imports(as % of merchandise exports) of Korea (Republic) in 2006 to that in 2008?
Offer a terse response. 0.94. What is the ratio of the Imports(as % of merchandise exports) of Mauritius in 2006 to that in 2008?
Ensure brevity in your answer.  0.79. What is the ratio of the Imports(as % of merchandise exports) in Azerbaijan in 2006 to that in 2009?
Your answer should be very brief. 0.66. What is the ratio of the Imports(as % of merchandise exports) of Bhutan in 2006 to that in 2009?
Your response must be concise. 1.42. What is the ratio of the Imports(as % of merchandise exports) in Korea (Republic) in 2006 to that in 2009?
Your response must be concise. 0.85. What is the ratio of the Imports(as % of merchandise exports) of Mauritius in 2006 to that in 2009?
Provide a succinct answer. 0.76. What is the ratio of the Imports(as % of merchandise exports) of Azerbaijan in 2006 to that in 2010?
Give a very brief answer. 0.56. What is the ratio of the Imports(as % of merchandise exports) of Bhutan in 2006 to that in 2010?
Give a very brief answer. 1.8. What is the ratio of the Imports(as % of merchandise exports) in Korea (Republic) in 2006 to that in 2010?
Provide a succinct answer. 0.93. What is the ratio of the Imports(as % of merchandise exports) in Mauritius in 2006 to that in 2010?
Provide a short and direct response. 0.78. What is the ratio of the Imports(as % of merchandise exports) in Azerbaijan in 2006 to that in 2011?
Keep it short and to the point. 0.74. What is the ratio of the Imports(as % of merchandise exports) in Bhutan in 2006 to that in 2011?
Give a very brief answer. 1.89. What is the ratio of the Imports(as % of merchandise exports) of Korea (Republic) in 2006 to that in 2011?
Provide a short and direct response. 0.87. What is the ratio of the Imports(as % of merchandise exports) of Mauritius in 2006 to that in 2011?
Ensure brevity in your answer.  0.77. What is the ratio of the Imports(as % of merchandise exports) of Azerbaijan in 2006 to that in 2012?
Offer a very short reply. 0.72. What is the ratio of the Imports(as % of merchandise exports) in Bhutan in 2006 to that in 2012?
Offer a very short reply. 1.5. What is the ratio of the Imports(as % of merchandise exports) in Korea (Republic) in 2006 to that in 2012?
Your response must be concise. 0.88. What is the ratio of the Imports(as % of merchandise exports) of Mauritius in 2006 to that in 2012?
Offer a terse response. 0.76. What is the ratio of the Imports(as % of merchandise exports) of Azerbaijan in 2007 to that in 2008?
Ensure brevity in your answer.  1.01. What is the ratio of the Imports(as % of merchandise exports) of Bhutan in 2007 to that in 2008?
Keep it short and to the point. 1.33. What is the ratio of the Imports(as % of merchandise exports) in Korea (Republic) in 2007 to that in 2008?
Offer a very short reply. 0.99. What is the ratio of the Imports(as % of merchandise exports) in Mauritius in 2007 to that in 2008?
Your answer should be compact. 0.9. What is the ratio of the Imports(as % of merchandise exports) in Bhutan in 2007 to that in 2009?
Provide a short and direct response. 1.47. What is the ratio of the Imports(as % of merchandise exports) of Korea (Republic) in 2007 to that in 2009?
Provide a succinct answer. 0.9. What is the ratio of the Imports(as % of merchandise exports) in Mauritius in 2007 to that in 2009?
Ensure brevity in your answer.  0.87. What is the ratio of the Imports(as % of merchandise exports) in Azerbaijan in 2007 to that in 2010?
Offer a terse response. 0.85. What is the ratio of the Imports(as % of merchandise exports) of Bhutan in 2007 to that in 2010?
Offer a terse response. 1.87. What is the ratio of the Imports(as % of merchandise exports) in Korea (Republic) in 2007 to that in 2010?
Give a very brief answer. 0.98. What is the ratio of the Imports(as % of merchandise exports) in Mauritius in 2007 to that in 2010?
Keep it short and to the point. 0.9. What is the ratio of the Imports(as % of merchandise exports) in Azerbaijan in 2007 to that in 2011?
Make the answer very short. 1.12. What is the ratio of the Imports(as % of merchandise exports) of Bhutan in 2007 to that in 2011?
Provide a short and direct response. 1.96. What is the ratio of the Imports(as % of merchandise exports) in Korea (Republic) in 2007 to that in 2011?
Offer a terse response. 0.92. What is the ratio of the Imports(as % of merchandise exports) of Mauritius in 2007 to that in 2011?
Your answer should be very brief. 0.89. What is the ratio of the Imports(as % of merchandise exports) of Azerbaijan in 2007 to that in 2012?
Give a very brief answer. 1.08. What is the ratio of the Imports(as % of merchandise exports) of Bhutan in 2007 to that in 2012?
Make the answer very short. 1.57. What is the ratio of the Imports(as % of merchandise exports) in Korea (Republic) in 2007 to that in 2012?
Ensure brevity in your answer.  0.93. What is the ratio of the Imports(as % of merchandise exports) of Mauritius in 2007 to that in 2012?
Provide a succinct answer. 0.88. What is the ratio of the Imports(as % of merchandise exports) in Azerbaijan in 2008 to that in 2009?
Your answer should be very brief. 0.99. What is the ratio of the Imports(as % of merchandise exports) of Bhutan in 2008 to that in 2009?
Provide a succinct answer. 1.11. What is the ratio of the Imports(as % of merchandise exports) of Korea (Republic) in 2008 to that in 2009?
Your response must be concise. 0.91. What is the ratio of the Imports(as % of merchandise exports) of Azerbaijan in 2008 to that in 2010?
Your answer should be compact. 0.84. What is the ratio of the Imports(as % of merchandise exports) in Bhutan in 2008 to that in 2010?
Provide a succinct answer. 1.41. What is the ratio of the Imports(as % of merchandise exports) in Mauritius in 2008 to that in 2010?
Offer a terse response. 0.99. What is the ratio of the Imports(as % of merchandise exports) of Azerbaijan in 2008 to that in 2011?
Provide a short and direct response. 1.11. What is the ratio of the Imports(as % of merchandise exports) in Bhutan in 2008 to that in 2011?
Give a very brief answer. 1.48. What is the ratio of the Imports(as % of merchandise exports) of Korea (Republic) in 2008 to that in 2011?
Give a very brief answer. 0.93. What is the ratio of the Imports(as % of merchandise exports) in Mauritius in 2008 to that in 2011?
Give a very brief answer. 0.98. What is the ratio of the Imports(as % of merchandise exports) of Azerbaijan in 2008 to that in 2012?
Provide a succinct answer. 1.07. What is the ratio of the Imports(as % of merchandise exports) of Bhutan in 2008 to that in 2012?
Your answer should be very brief. 1.18. What is the ratio of the Imports(as % of merchandise exports) in Korea (Republic) in 2008 to that in 2012?
Make the answer very short. 0.94. What is the ratio of the Imports(as % of merchandise exports) in Mauritius in 2008 to that in 2012?
Offer a very short reply. 0.97. What is the ratio of the Imports(as % of merchandise exports) of Azerbaijan in 2009 to that in 2010?
Offer a terse response. 0.85. What is the ratio of the Imports(as % of merchandise exports) in Bhutan in 2009 to that in 2010?
Provide a short and direct response. 1.27. What is the ratio of the Imports(as % of merchandise exports) of Korea (Republic) in 2009 to that in 2010?
Make the answer very short. 1.1. What is the ratio of the Imports(as % of merchandise exports) of Mauritius in 2009 to that in 2010?
Keep it short and to the point. 1.02. What is the ratio of the Imports(as % of merchandise exports) of Azerbaijan in 2009 to that in 2011?
Provide a short and direct response. 1.12. What is the ratio of the Imports(as % of merchandise exports) of Bhutan in 2009 to that in 2011?
Provide a succinct answer. 1.33. What is the ratio of the Imports(as % of merchandise exports) in Korea (Republic) in 2009 to that in 2011?
Keep it short and to the point. 1.02. What is the ratio of the Imports(as % of merchandise exports) in Mauritius in 2009 to that in 2011?
Provide a succinct answer. 1.01. What is the ratio of the Imports(as % of merchandise exports) of Azerbaijan in 2009 to that in 2012?
Your answer should be compact. 1.08. What is the ratio of the Imports(as % of merchandise exports) of Bhutan in 2009 to that in 2012?
Offer a very short reply. 1.06. What is the ratio of the Imports(as % of merchandise exports) in Korea (Republic) in 2009 to that in 2012?
Offer a very short reply. 1.03. What is the ratio of the Imports(as % of merchandise exports) of Azerbaijan in 2010 to that in 2011?
Provide a succinct answer. 1.31. What is the ratio of the Imports(as % of merchandise exports) in Bhutan in 2010 to that in 2011?
Provide a short and direct response. 1.05. What is the ratio of the Imports(as % of merchandise exports) of Korea (Republic) in 2010 to that in 2011?
Give a very brief answer. 0.93. What is the ratio of the Imports(as % of merchandise exports) in Azerbaijan in 2010 to that in 2012?
Keep it short and to the point. 1.27. What is the ratio of the Imports(as % of merchandise exports) in Bhutan in 2010 to that in 2012?
Offer a terse response. 0.84. What is the ratio of the Imports(as % of merchandise exports) of Korea (Republic) in 2010 to that in 2012?
Offer a terse response. 0.94. What is the ratio of the Imports(as % of merchandise exports) of Mauritius in 2010 to that in 2012?
Your response must be concise. 0.98. What is the ratio of the Imports(as % of merchandise exports) of Azerbaijan in 2011 to that in 2012?
Make the answer very short. 0.97. What is the ratio of the Imports(as % of merchandise exports) in Bhutan in 2011 to that in 2012?
Offer a very short reply. 0.8. What is the ratio of the Imports(as % of merchandise exports) in Korea (Republic) in 2011 to that in 2012?
Provide a succinct answer. 1.01. What is the ratio of the Imports(as % of merchandise exports) of Mauritius in 2011 to that in 2012?
Your response must be concise. 0.99. What is the difference between the highest and the second highest Imports(as % of merchandise exports) in Azerbaijan?
Make the answer very short. 2.73. What is the difference between the highest and the second highest Imports(as % of merchandise exports) in Bhutan?
Ensure brevity in your answer.  0.86. What is the difference between the highest and the second highest Imports(as % of merchandise exports) of Korea (Republic)?
Keep it short and to the point. 0.1. What is the difference between the highest and the second highest Imports(as % of merchandise exports) of Mauritius?
Offer a terse response. 0.03. What is the difference between the highest and the lowest Imports(as % of merchandise exports) of Azerbaijan?
Offer a terse response. 8.09. What is the difference between the highest and the lowest Imports(as % of merchandise exports) of Bhutan?
Give a very brief answer. 10.55. What is the difference between the highest and the lowest Imports(as % of merchandise exports) in Korea (Republic)?
Provide a succinct answer. 0.73. What is the difference between the highest and the lowest Imports(as % of merchandise exports) in Mauritius?
Give a very brief answer. 5.11. 